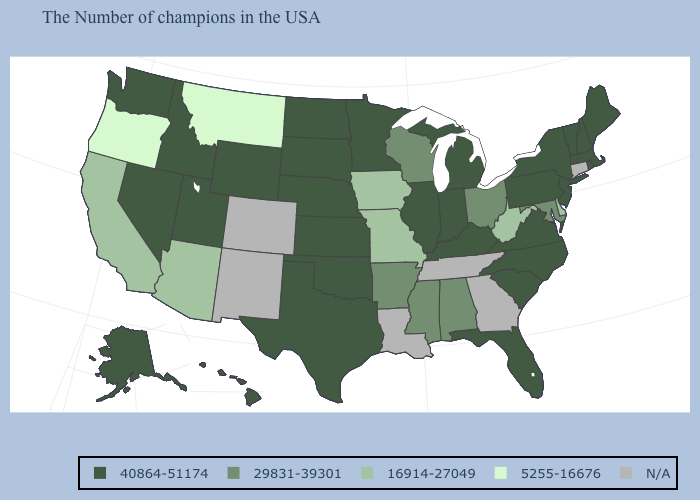Among the states that border California , does Oregon have the lowest value?
Quick response, please. Yes. What is the value of Wisconsin?
Keep it brief. 29831-39301. Which states have the lowest value in the USA?
Give a very brief answer. Montana, Oregon. Name the states that have a value in the range 29831-39301?
Give a very brief answer. Maryland, Ohio, Alabama, Wisconsin, Mississippi, Arkansas. What is the lowest value in states that border Ohio?
Be succinct. 16914-27049. Which states have the lowest value in the Northeast?
Be succinct. Maine, Massachusetts, Rhode Island, New Hampshire, Vermont, New York, New Jersey, Pennsylvania. Among the states that border Wisconsin , does Iowa have the highest value?
Quick response, please. No. Name the states that have a value in the range 16914-27049?
Write a very short answer. Delaware, West Virginia, Missouri, Iowa, Arizona, California. Name the states that have a value in the range 40864-51174?
Keep it brief. Maine, Massachusetts, Rhode Island, New Hampshire, Vermont, New York, New Jersey, Pennsylvania, Virginia, North Carolina, South Carolina, Florida, Michigan, Kentucky, Indiana, Illinois, Minnesota, Kansas, Nebraska, Oklahoma, Texas, South Dakota, North Dakota, Wyoming, Utah, Idaho, Nevada, Washington, Alaska, Hawaii. What is the lowest value in the West?
Quick response, please. 5255-16676. Name the states that have a value in the range 29831-39301?
Answer briefly. Maryland, Ohio, Alabama, Wisconsin, Mississippi, Arkansas. What is the value of Tennessee?
Give a very brief answer. N/A. Does Oregon have the highest value in the West?
Concise answer only. No. 